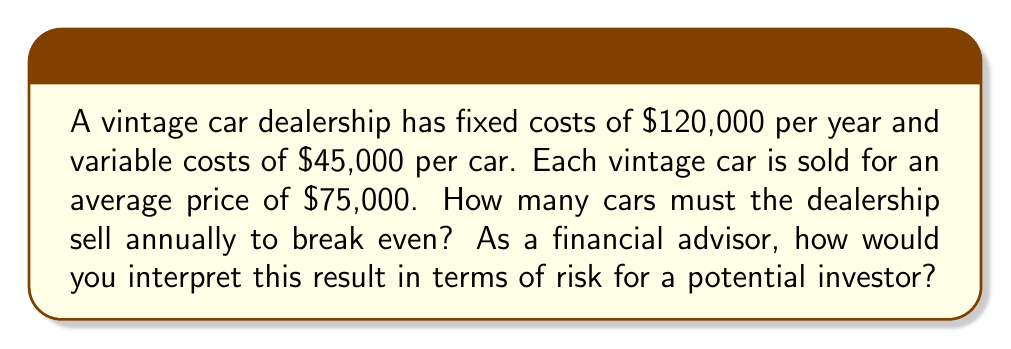Give your solution to this math problem. To solve this problem, we need to use the break-even analysis formula. The break-even point is where total revenue equals total costs.

Let's define our variables:
$x$ = number of cars sold
$P$ = price per car
$F$ = fixed costs
$V$ = variable cost per car

The break-even formula is:

$$ Px = F + Vx $$

Substituting our values:

$$ 75,000x = 120,000 + 45,000x $$

Now, let's solve for $x$:

$$ 75,000x - 45,000x = 120,000 $$
$$ 30,000x = 120,000 $$
$$ x = \frac{120,000}{30,000} = 4 $$

Therefore, the dealership needs to sell 4 cars to break even.

From a financial advisor's perspective, this result indicates a relatively high risk. Selling 4 vintage cars per year might seem achievable, but several factors should be considered:

1. The vintage car market can be volatile and subject to economic fluctuations.
2. Each unsold car represents a significant portion of the break-even target.
3. The high variable cost per car ($45,000) leaves a relatively small profit margin.
4. Fixed costs are substantial, putting pressure on the business to maintain sales.

An investor should carefully consider these factors and the dealership's historical performance before making an investment decision.
Answer: The vintage car dealership must sell 4 cars annually to break even. 